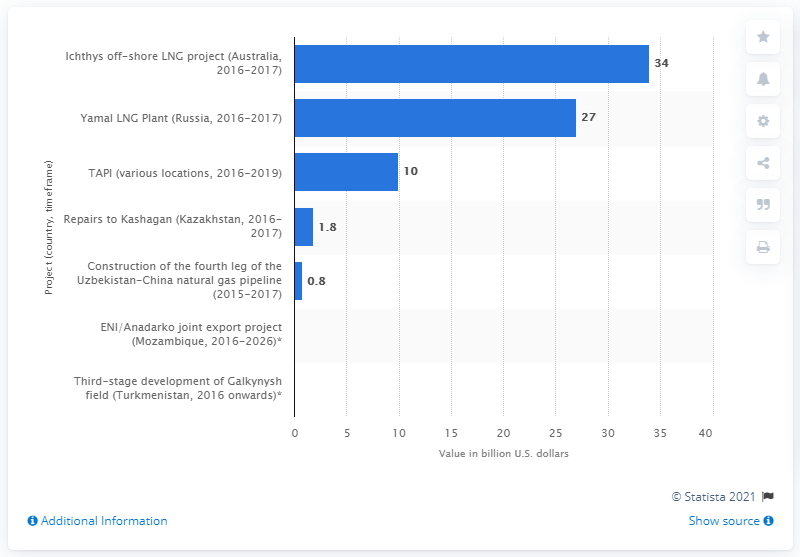Give some essential details in this illustration. The estimated cost of the Ichthys off-shore LNG project in Australia is approximately 34. 